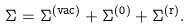<formula> <loc_0><loc_0><loc_500><loc_500>\Sigma = \Sigma ^ { ( \text {vac} ) } + \Sigma ^ { ( 0 ) } + \Sigma ^ { ( \text {r} ) } .</formula> 